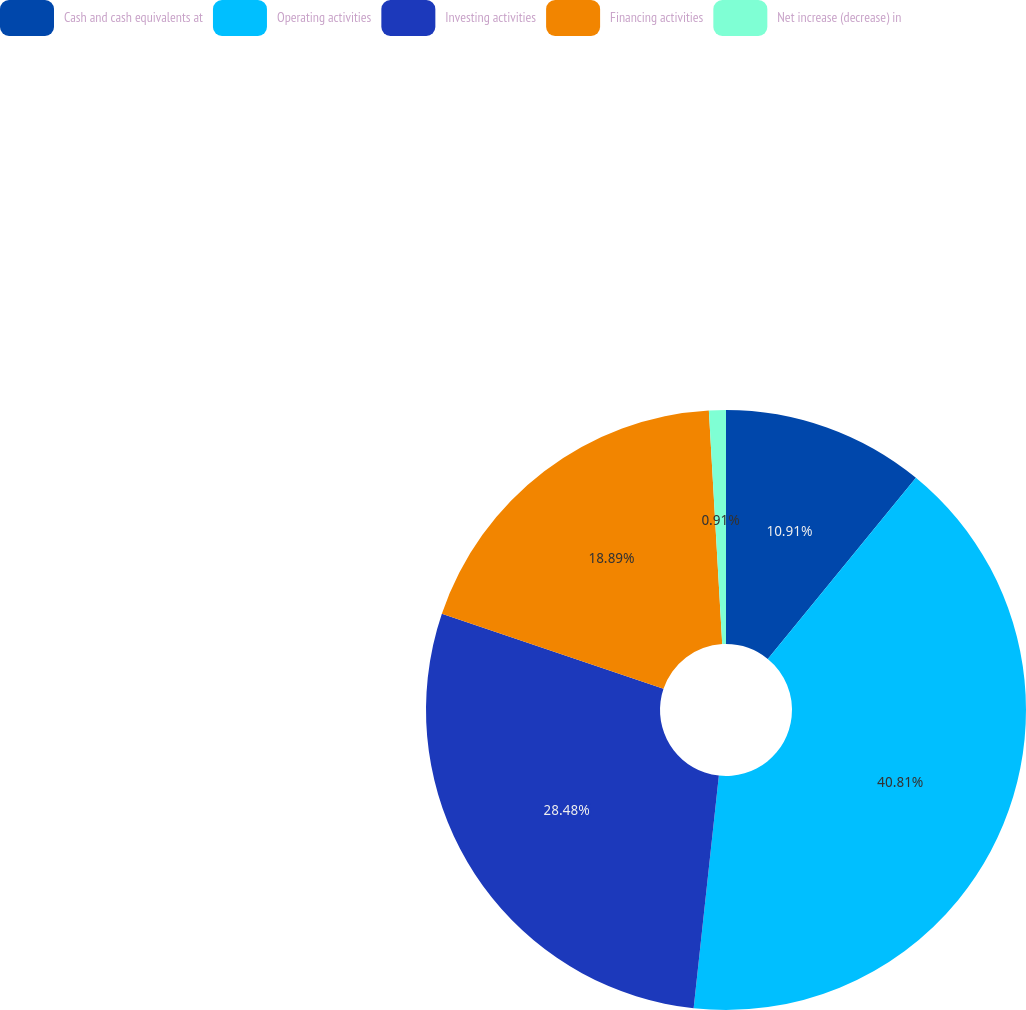Convert chart to OTSL. <chart><loc_0><loc_0><loc_500><loc_500><pie_chart><fcel>Cash and cash equivalents at<fcel>Operating activities<fcel>Investing activities<fcel>Financing activities<fcel>Net increase (decrease) in<nl><fcel>10.91%<fcel>40.81%<fcel>28.48%<fcel>18.89%<fcel>0.91%<nl></chart> 